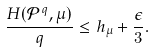Convert formula to latex. <formula><loc_0><loc_0><loc_500><loc_500>\frac { H ( { \mathcal { P } } ^ { q } , \mu ) } { q } \leq h _ { \mu } + \frac { \epsilon } { 3 } .</formula> 